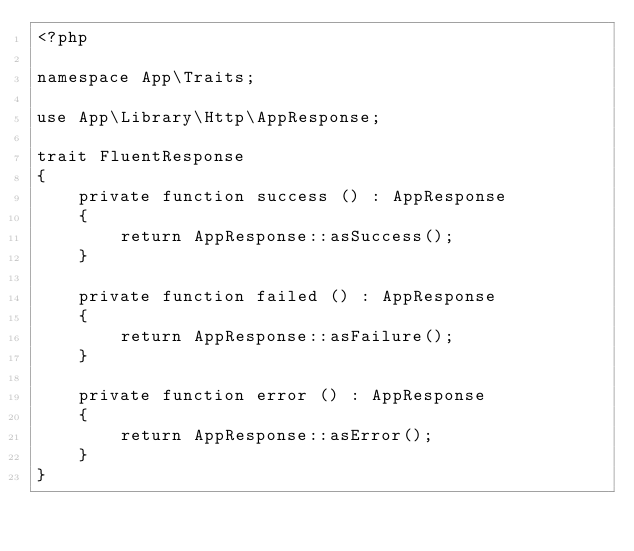<code> <loc_0><loc_0><loc_500><loc_500><_PHP_><?php

namespace App\Traits;

use App\Library\Http\AppResponse;

trait FluentResponse
{
	private function success () : AppResponse
	{
		return AppResponse::asSuccess();
	}

	private function failed () : AppResponse
	{
		return AppResponse::asFailure();
	}

	private function error () : AppResponse
	{
		return AppResponse::asError();
	}
}</code> 